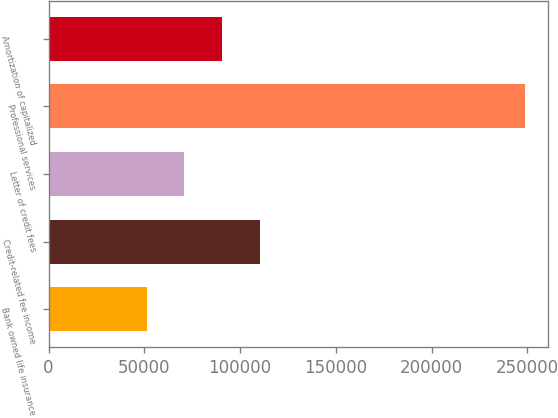Convert chart. <chart><loc_0><loc_0><loc_500><loc_500><bar_chart><fcel>Bank owned life insurance<fcel>Credit-related fee income<fcel>Letter of credit fees<fcel>Professional services<fcel>Amortization of capitalized<nl><fcel>51199<fcel>110402<fcel>70933.5<fcel>248544<fcel>90668<nl></chart> 